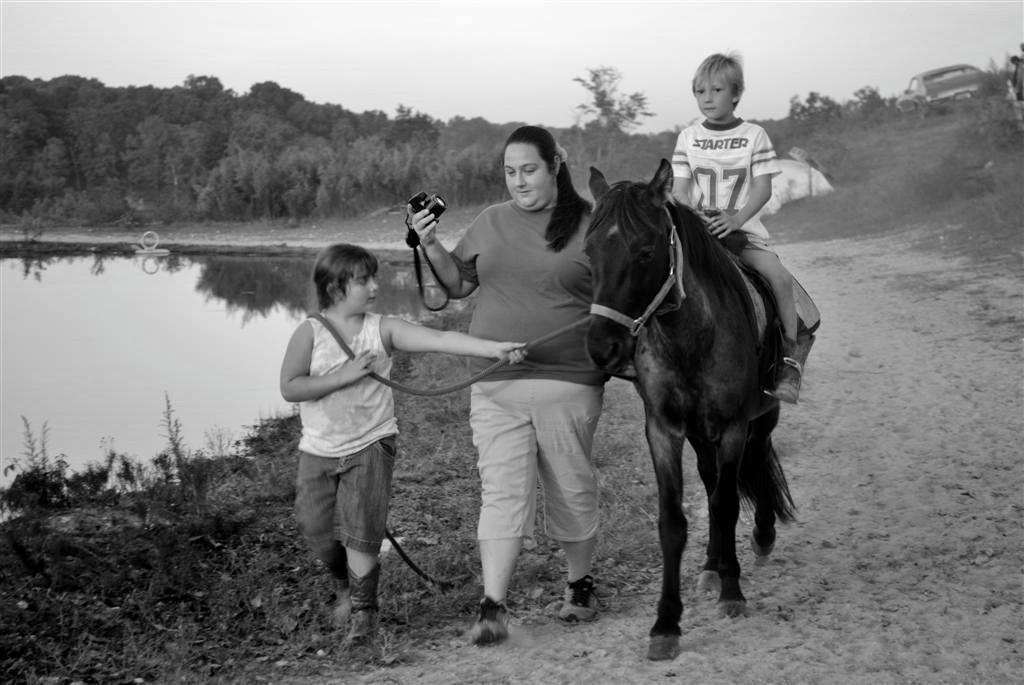Describe this image in one or two sentences. This image consists of their humans and a horse. It is clicked outside the city. A boy is holding the rope. On the horse boy wearing white t-shirt is sitting. Beside the horse, the woman holding camera is walking. To the left, there is a pond. In the background there are trees and plants. 